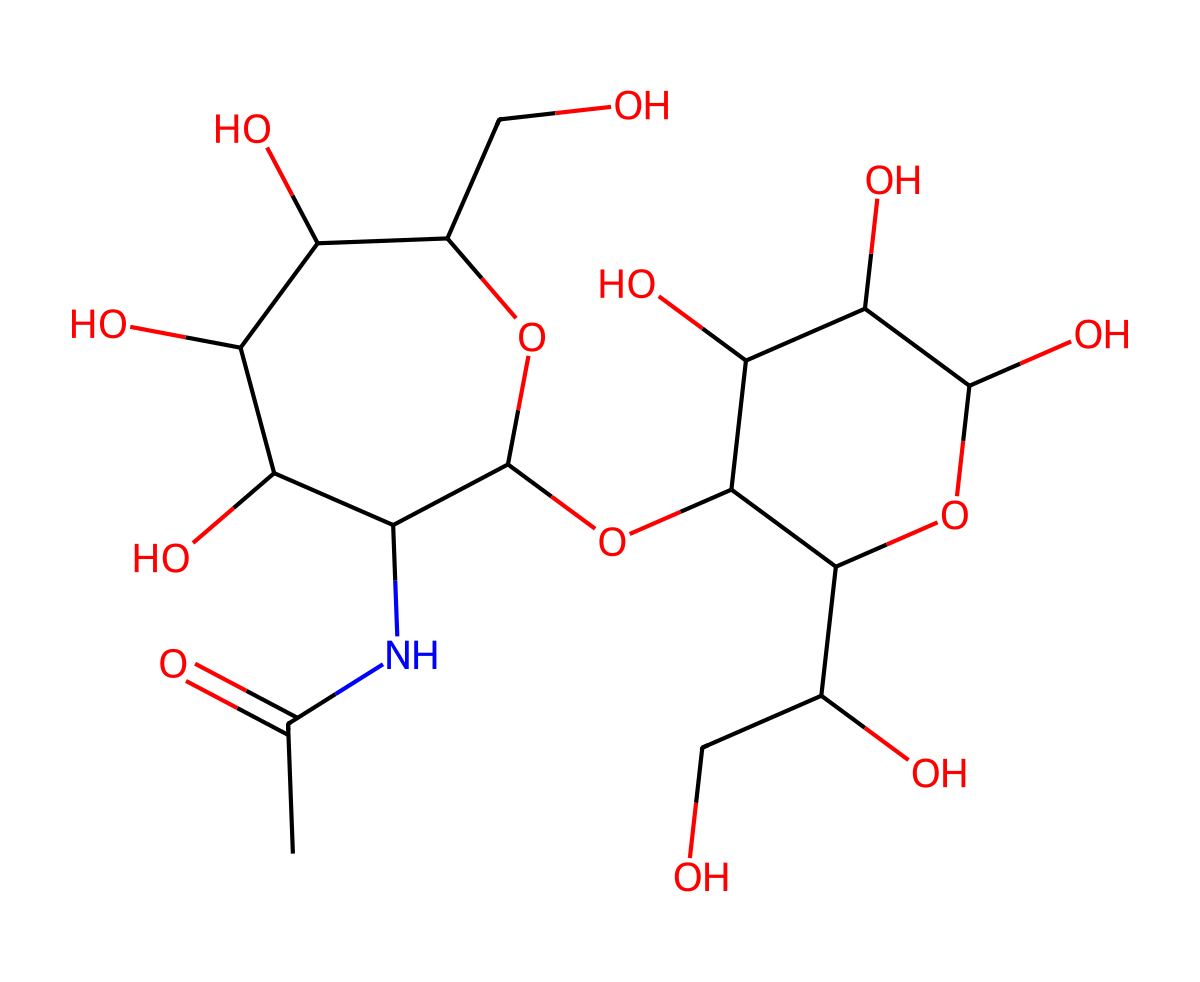What is the primary functional group present in hyaluronic acid? Examining the structure, the primary functional group is the amide groups indicated by the presence of a nitrogen atom connected to a carbonyl (C=O) followed by an alkyl chain.
Answer: amide How many carbon atoms are present in hyaluronic acid? By visual inspection of the structure, counting all the carbon atoms reveals a total of 20 carbon atoms in the molecule.
Answer: 20 What type of carbohydrate is hyaluronic acid classified as? Considering its structure, hyaluronic acid is classified as a glycosaminoglycan, which is a long unbranched carbohydrate made from repeating disaccharides.
Answer: glycosaminoglycan How many hydroxyl (-OH) groups are present in hyaluronic acid? Analyzing the structure, hydroxyl groups are indicated at various positions, leading to a total count of 6 hydroxyl groups in the molecule.
Answer: 6 What role does hyaluronic acid play in joints? Understanding its function in the body, hyaluronic acid serves mainly as a lubricant and shock absorber within synovial fluid, essential for joint function.
Answer: lubricant Which linkage is present between the sugar units in hyaluronic acid? The sugar units in hyaluronic acid are linked by β-(1→4) and β-(1→3) glycosidic bonds, which are characteristic of its repeating disaccharide structure.
Answer: glycosidic 